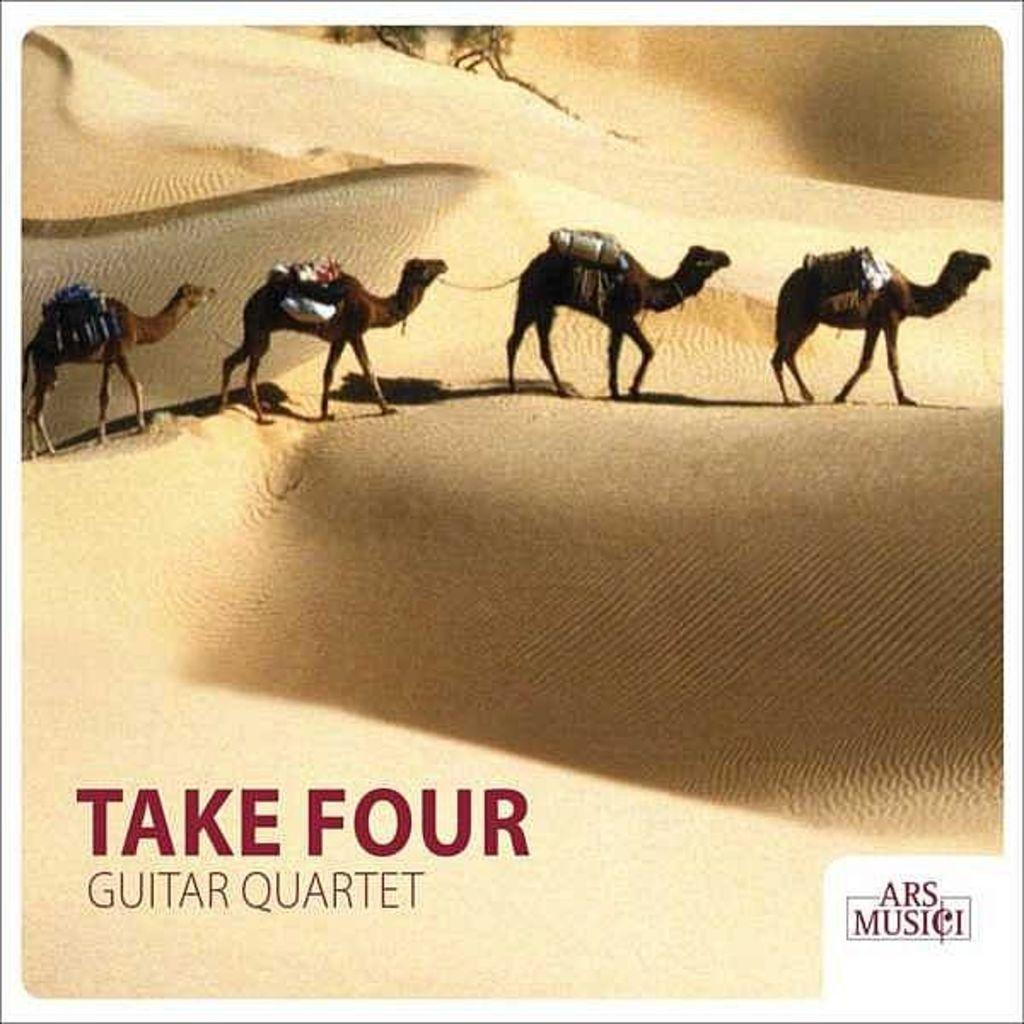In one or two sentences, can you explain what this image depicts? In this image we can see four camels carrying bags on them are standing on the dessert. At the bottom of the image we can see a text. 